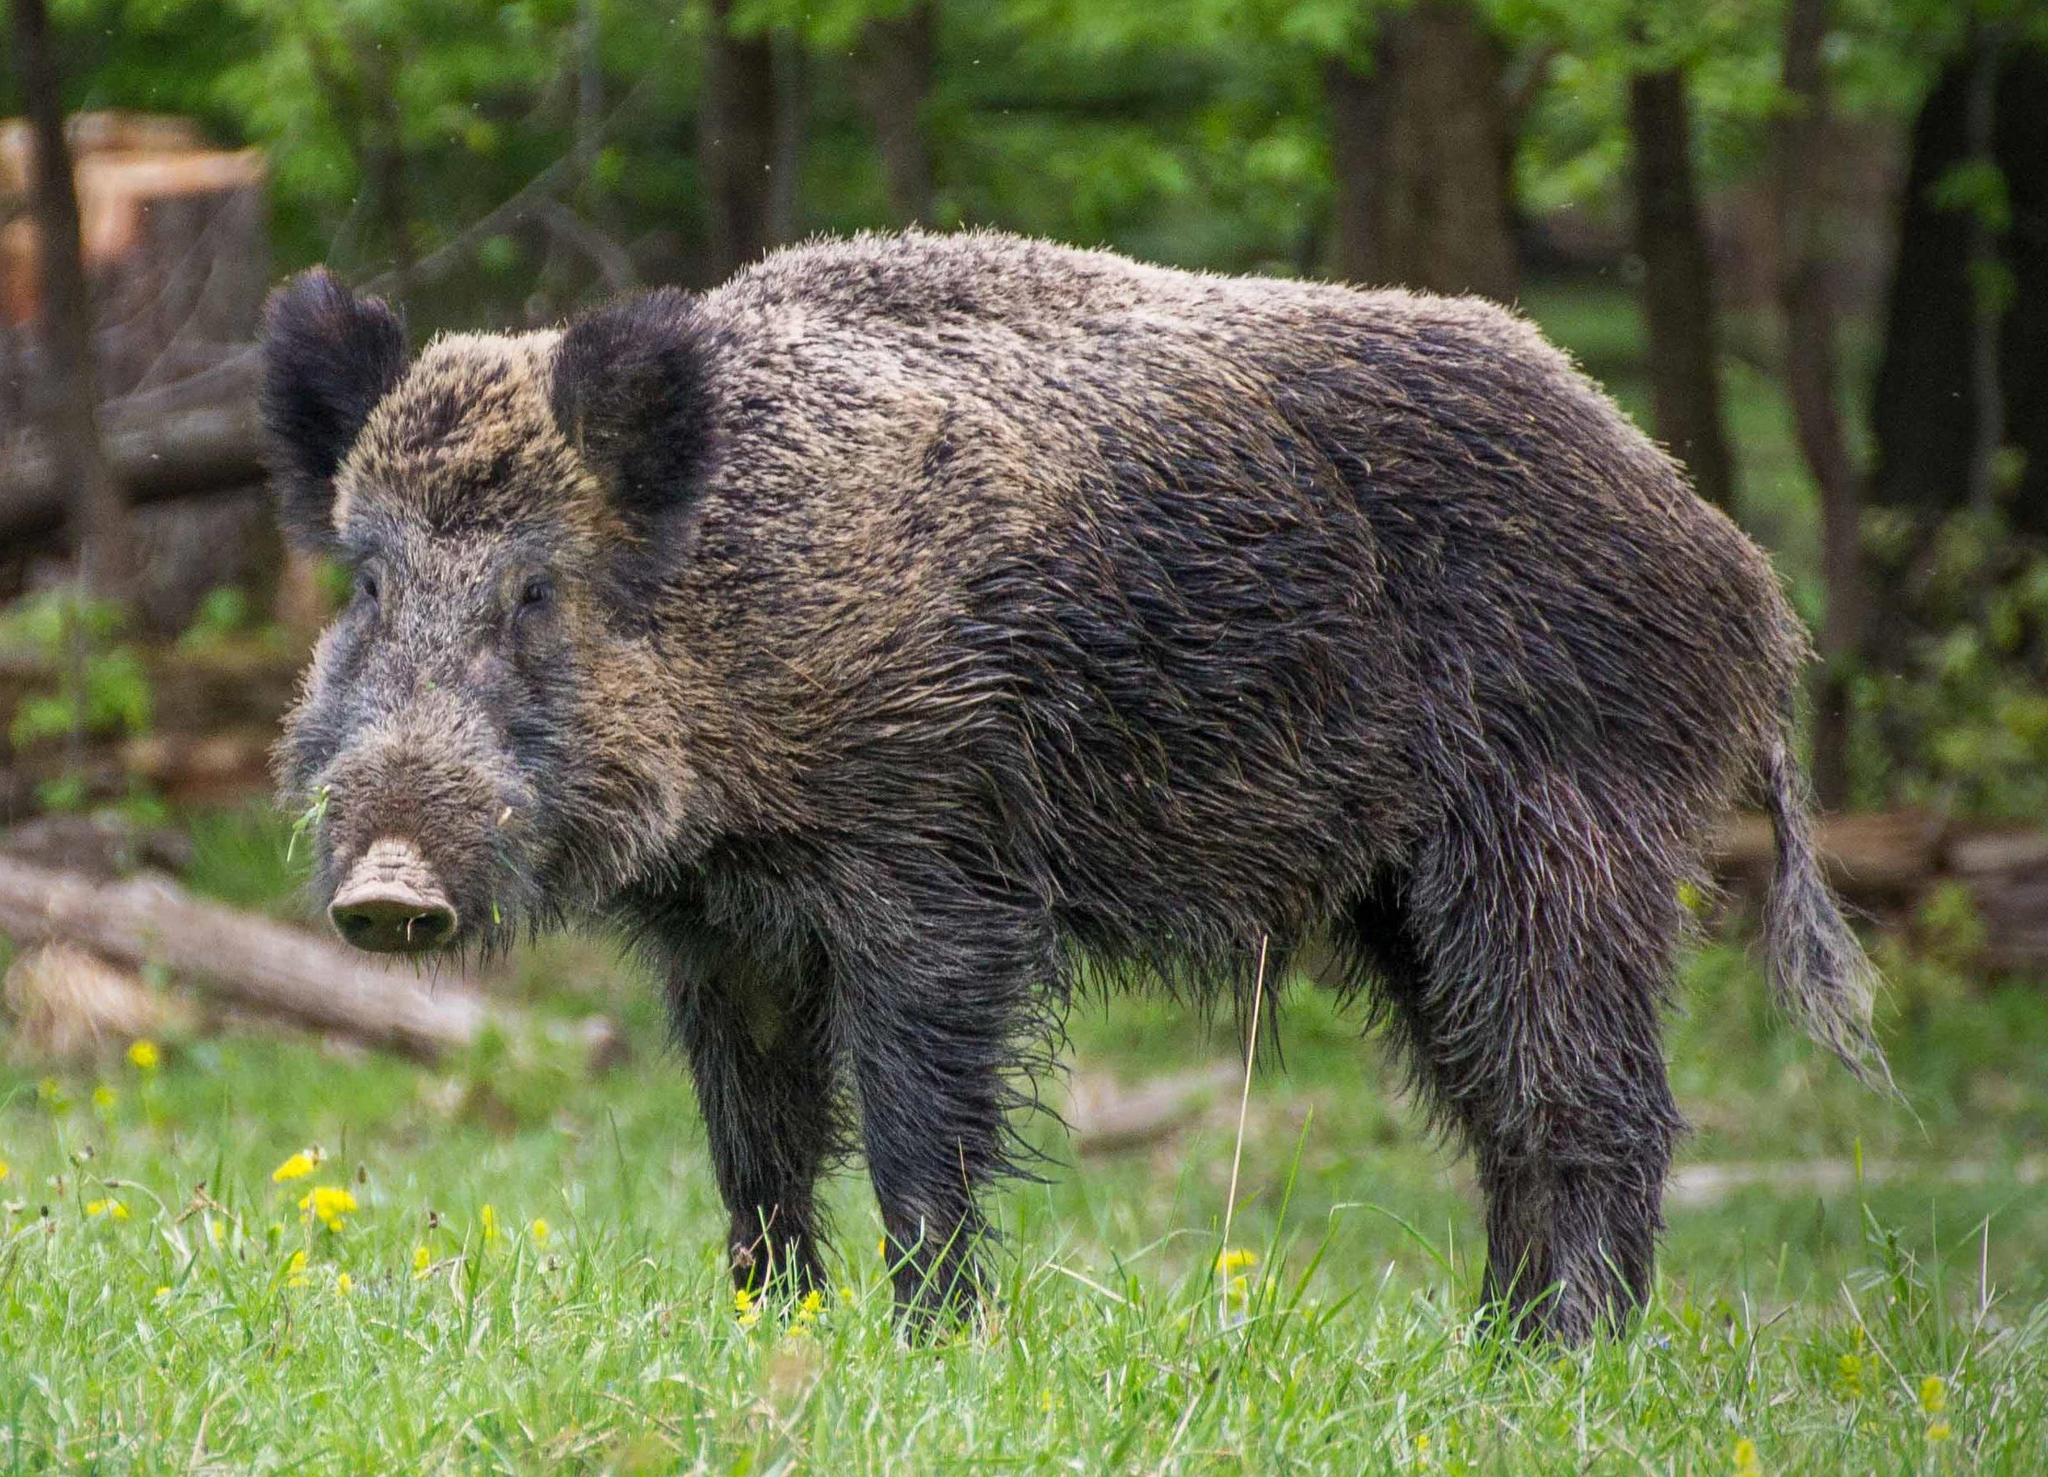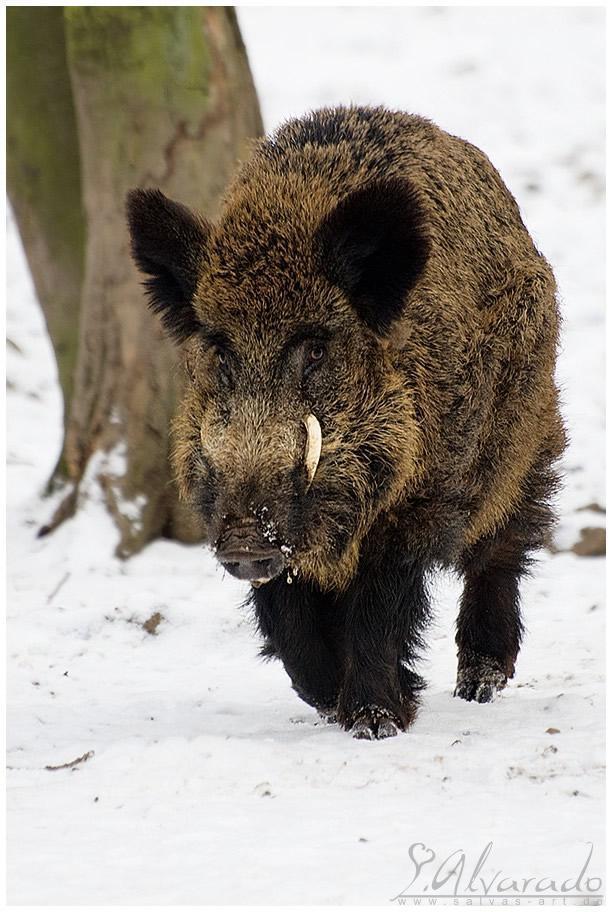The first image is the image on the left, the second image is the image on the right. For the images displayed, is the sentence "At least one hog walks through the snow." factually correct? Answer yes or no. Yes. The first image is the image on the left, the second image is the image on the right. Examine the images to the left and right. Is the description "There are no more that two pigs standing in lush green grass." accurate? Answer yes or no. Yes. 